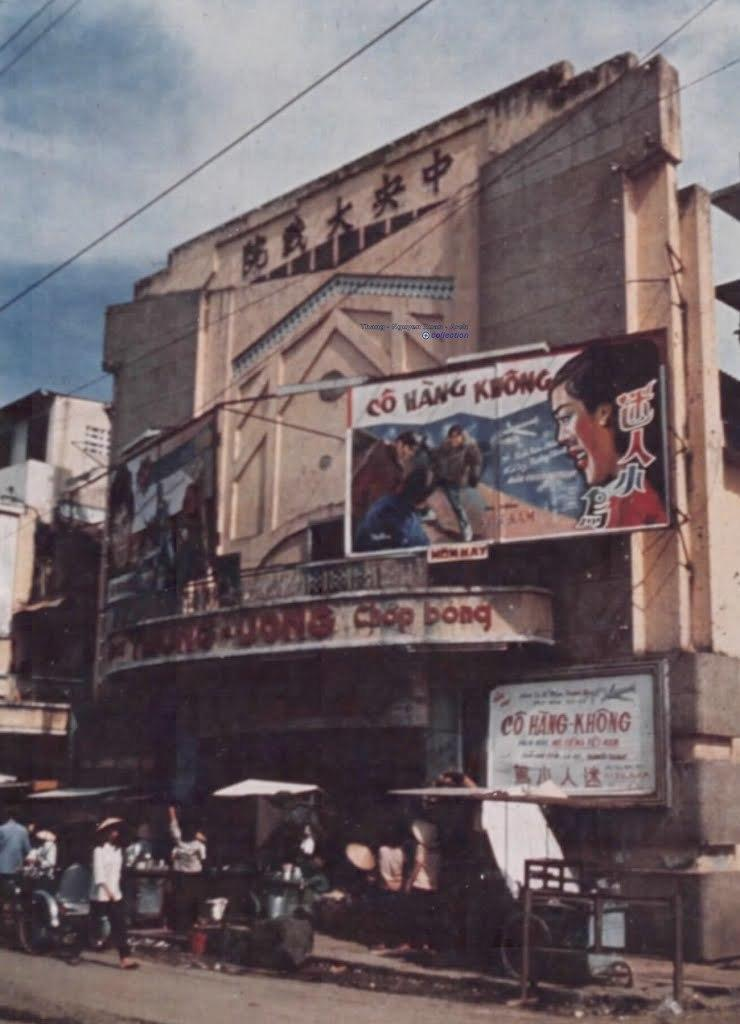What is the main structure in the picture? There is a building in the picture. What is attached to the building? The building has banners. What is happening on the road in front of the building? There are people walking on the road. What can be seen above the road and the building? Electric cables are visible. What is the condition of the sky in the picture? The sky is clear in the picture. What type of berry is being discussed by the committee in the image? There is no committee or berry present in the image. How low are the people walking on the road in the image? The image does not provide information about the height or position of the people walking on the road, only that they are walking. 